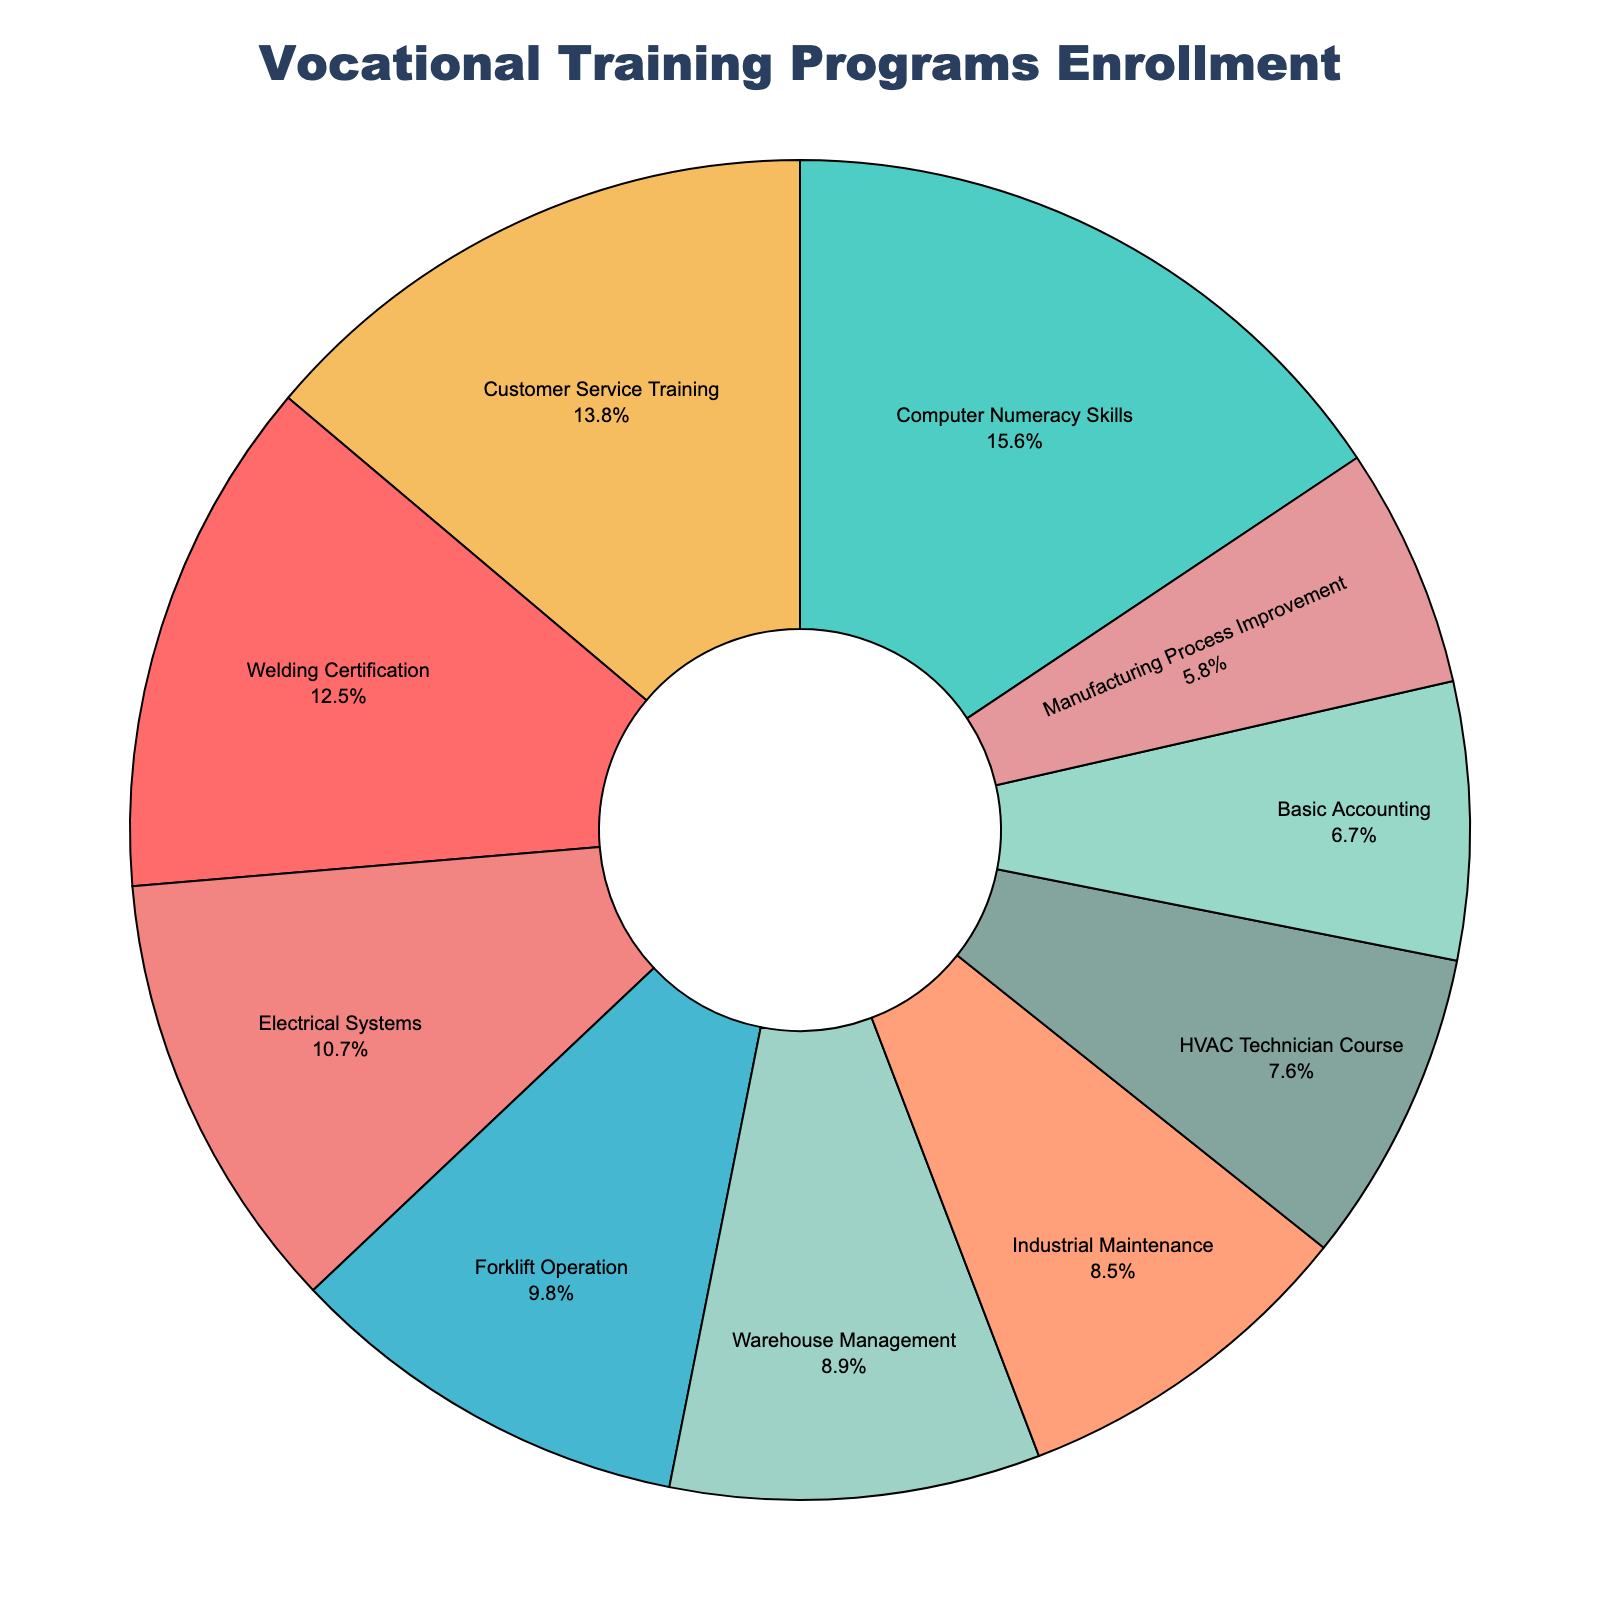What percentage of the enrollment is for the Computer Numeracy Skills program? The Computer Numeracy Skills program has a slice in the pie chart. You can directly read the percentage from the figure, which indicates the portion of the enrollment.
Answer: 18.9% Which program has the highest enrollment? To find the program with the highest enrollment, look for the largest slice in the pie chart. The label inside the largest slice will show the program name and its percentage.
Answer: Computer Numeracy Skills What is the combined percentage of the Welding Certification and Forklift Operation programs? Find the percentages for the Welding Certification and Forklift Operation programs on the pie chart, then sum them up. Welding Certification is 15.1% and Forklift Operation is 11.9%, so their total is 15.1% + 11.9% = 27%.
Answer: 27% Which program has a larger enrollment: Warehouse Management or HVAC Technician Course? Compare the sizes of the slices for Warehouse Management and HVAC Technician Course. Warehouse Management has a percentage label indicating 10.8%, while HVAC Technician Course shows 9.2%. Therefore, Warehouse Management is larger.
Answer: Warehouse Management Which program has the smallest enrollment? Identify the smallest slice in the pie chart. The label within this slice will show the program name and its percentage.
Answer: Manufacturing Process Improvement How many more people are enrolled in Customer Service Training than in Basic Accounting? Find the enrollment numbers for both programs and subtract the smaller from the larger. Customer Service Training has 31 enrollments, and Basic Accounting has 15 enrollments. The difference is 31 - 15 = 16.
Answer: 16 Which programs have enrollments greater than 20 people? Check each slice in the pie chart with enrollments greater than 20. Welding Certification (28), Computer Numeracy Skills (35), Forklift Operation (22), Customer Service Training (31), Electrical Systems (24). These programs fit the criteria.
Answer: Welding Certification, Computer Numeracy Skills, Forklift Operation, Customer Service Training, Electrical Systems If the enrollment for Electrical Systems increased by 3, what would the new total be? Add 3 to the current enrollment of the Electrical Systems program. The current enrollment is 24, so the new total is 24 + 3 = 27.
Answer: 27 What is the average enrollment across all programs? Calculate the sum of enrollments for all programs and divide by the number of programs. The total enrollment is 224 and there are 10 programs. So, the average is 224 / 10 = 22.4.
Answer: 22.4 Is the enrollment in Industrial Maintenance closer to that of Forklift Operation or to that of Basic Accounting? Check the enrollment numbers: Industrial Maintenance has 19, Forklift Operation has 22, and Basic Accounting has 15. The difference between Industrial Maintenance and Forklift Operation is
Answer: Industrial Maintenance 